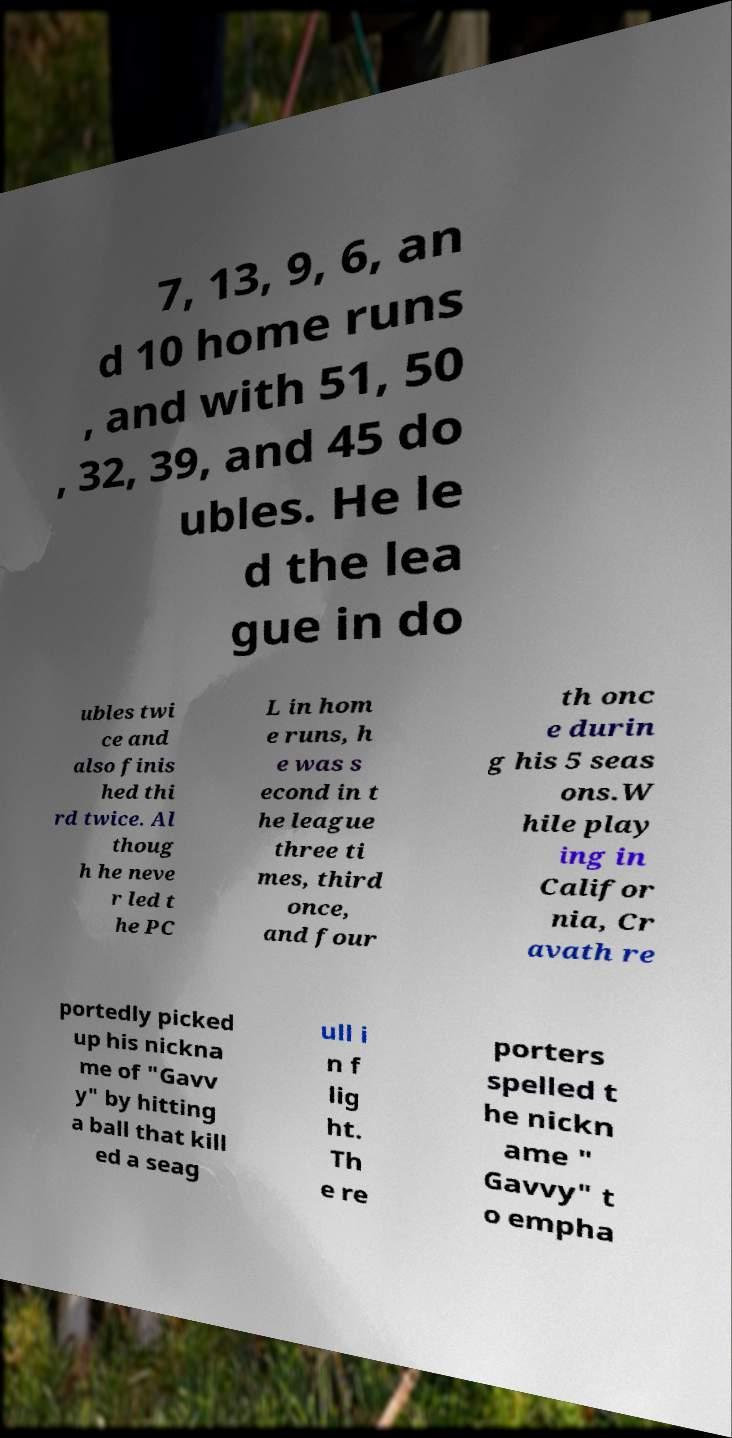For documentation purposes, I need the text within this image transcribed. Could you provide that? 7, 13, 9, 6, an d 10 home runs , and with 51, 50 , 32, 39, and 45 do ubles. He le d the lea gue in do ubles twi ce and also finis hed thi rd twice. Al thoug h he neve r led t he PC L in hom e runs, h e was s econd in t he league three ti mes, third once, and four th onc e durin g his 5 seas ons.W hile play ing in Califor nia, Cr avath re portedly picked up his nickna me of "Gavv y" by hitting a ball that kill ed a seag ull i n f lig ht. Th e re porters spelled t he nickn ame " Gavvy" t o empha 